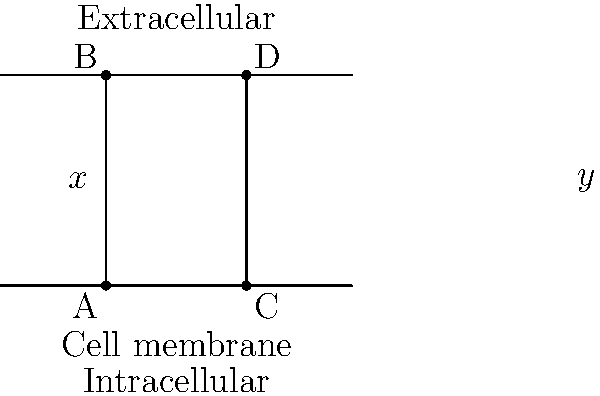In the diagram, two parallel lines represent a cell membrane, with a transversal line depicting a transport protein. If the angle marked $x°$ represents the angle of entry for a molecule into the transport protein, and $y°$ represents the angle of exit, what is the relationship between $x$ and $y$? How does this geometric relationship relate to the energy requirements for passive diffusion across a cell membrane? To answer this question, let's follow these steps:

1) In geometry, when a transversal line intersects two parallel lines, corresponding angles are congruent. This means that $x° = y°$.

2) This geometric relationship can be related to passive diffusion across a cell membrane:

   a) Passive diffusion is a process where molecules move from an area of high concentration to an area of low concentration without the expenditure of cellular energy.

   b) The equality of angles ($x° = y°$) can be interpreted as representing the lack of energy input in passive diffusion. The molecule enters and exits the membrane at the same angle, suggesting no additional force or energy is applied to change its trajectory.

3) If the angles were not equal (i.e., if $x° \neq y°$), it would imply that some force or energy is being applied to change the direction of the molecule as it passes through the membrane. This would be more representative of active transport, which requires energy input.

4) The parallel lines of the cell membrane represent the phospholipid bilayer. The transversal line could represent a channel protein facilitating passive diffusion.

5) In biochemical terms, the equality of angles suggests that the activation energy for entry and exit of the molecule is the same, which is characteristic of passive diffusion processes.

This geometric representation provides a visual analogy for the energy-independent nature of passive diffusion across cell membranes.
Answer: $x° = y°$, representing no energy expenditure in passive diffusion. 